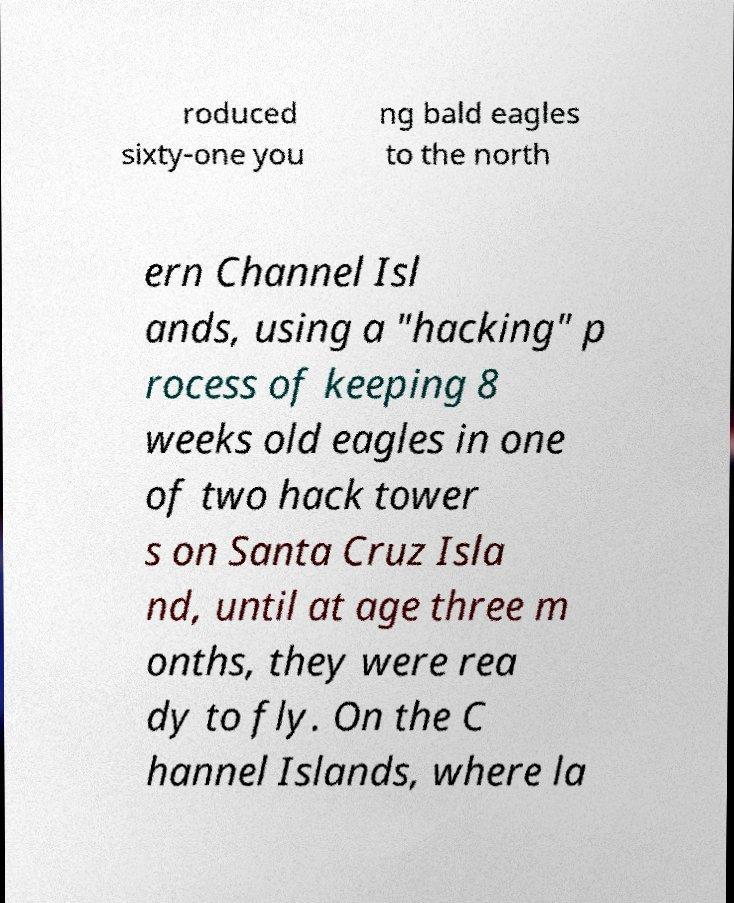Please read and relay the text visible in this image. What does it say? roduced sixty-one you ng bald eagles to the north ern Channel Isl ands, using a "hacking" p rocess of keeping 8 weeks old eagles in one of two hack tower s on Santa Cruz Isla nd, until at age three m onths, they were rea dy to fly. On the C hannel Islands, where la 